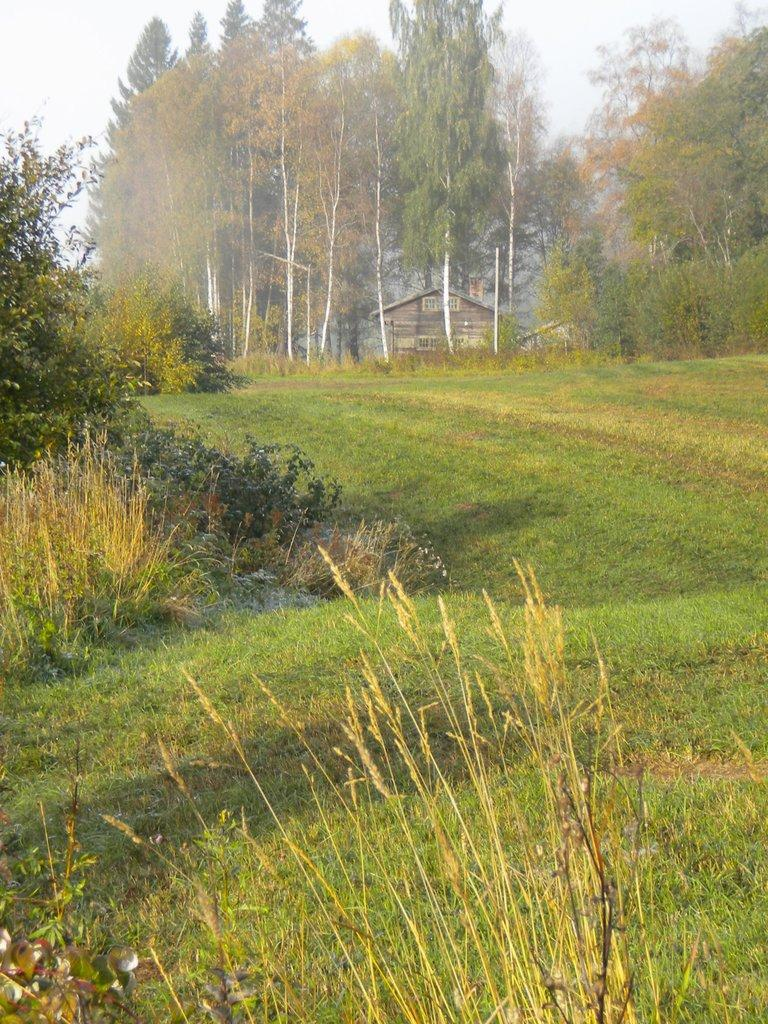What type of vegetation is present in the image? There are trees in the image. What else can be seen on the ground in the image? There is grass in the image. What type of structure is visible in the image? There is a house in the image. What is visible above the trees and house in the image? The sky is visible in the image. Can you tell me how many gloves are hanging from the trees in the image? There are no gloves present in the image; it features trees, grass, a house, and the sky. What type of hearing device can be seen on the roof of the house in the image? There is no hearing device visible on the roof of the house in the image. 